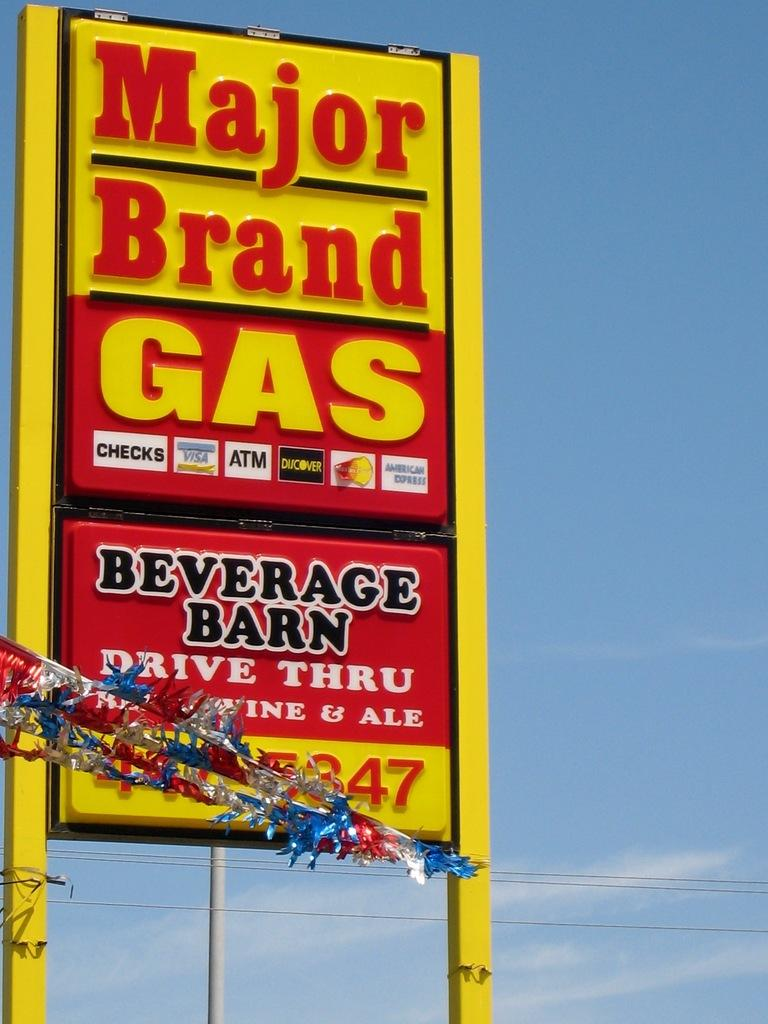<image>
Present a compact description of the photo's key features. A large yellow and red sign for Major brand Gas and Beverage Barn. 